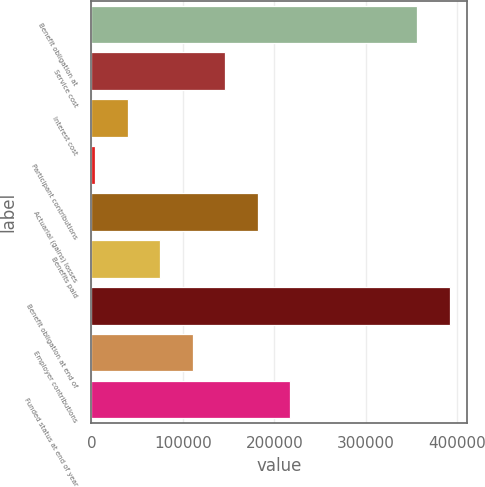<chart> <loc_0><loc_0><loc_500><loc_500><bar_chart><fcel>Benefit obligation at<fcel>Service cost<fcel>Interest cost<fcel>Participant contributions<fcel>Actuarial (gains) losses<fcel>Benefits paid<fcel>Benefit obligation at end of<fcel>Employer contributions<fcel>Funded status at end of year<nl><fcel>355766<fcel>146147<fcel>39512.8<fcel>3968<fcel>181692<fcel>75057.6<fcel>391311<fcel>110602<fcel>217237<nl></chart> 